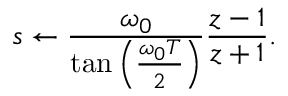<formula> <loc_0><loc_0><loc_500><loc_500>s \leftarrow { \frac { \omega _ { 0 } } { \tan \left ( { \frac { \omega _ { 0 } T } { 2 } } \right ) } } { \frac { z - 1 } { z + 1 } } .</formula> 